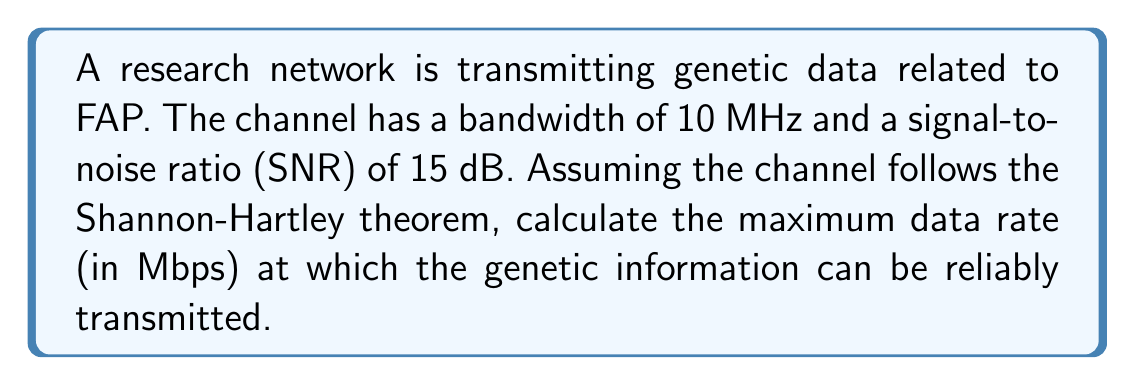Solve this math problem. To solve this problem, we'll use the Shannon-Hartley theorem, which gives the channel capacity for a noisy channel. The theorem is expressed as:

$$C = B \log_2(1 + SNR)$$

Where:
$C$ = Channel capacity (bits per second)
$B$ = Bandwidth (Hz)
$SNR$ = Signal-to-Noise Ratio (linear scale)

Given:
- Bandwidth ($B$) = 10 MHz = $10 \times 10^6$ Hz
- SNR = 15 dB

Step 1: Convert SNR from dB to linear scale
$SNR_{linear} = 10^{(SNR_{dB}/10)} = 10^{(15/10)} = 10^{1.5} \approx 31.6228$

Step 2: Apply the Shannon-Hartley theorem
$$\begin{align}
C &= B \log_2(1 + SNR) \\
&= (10 \times 10^6) \log_2(1 + 31.6228) \\
&= (10 \times 10^6) \log_2(32.6228) \\
&\approx (10 \times 10^6) \times 5.0279 \\
&\approx 50.279 \times 10^6 \text{ bits per second}
\end{align}$$

Step 3: Convert bits per second to Megabits per second (Mbps)
$$50.279 \times 10^6 \text{ bps} = 50.279 \text{ Mbps}$$

Therefore, the maximum data rate at which genetic information related to FAP can be reliably transmitted in this research network is approximately 50.279 Mbps.
Answer: 50.279 Mbps 